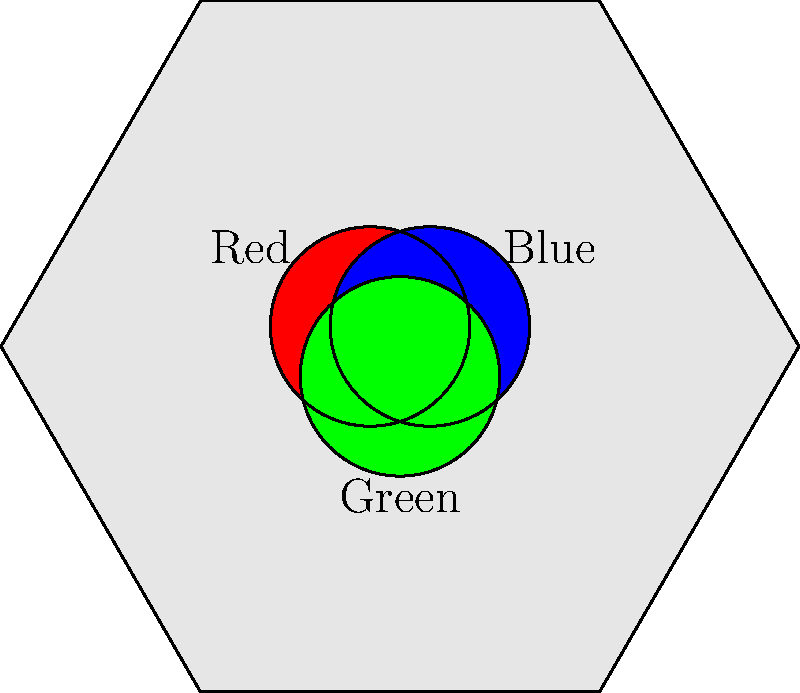Grandpa's old motorcycle jacket has three colorful patches: red, blue, and green. He tells you that he used to rearrange these patches to create different looks. How many unique ways could Grandpa arrange these three patches on his jacket? Let's approach this step-by-step:

1. We have three distinct patches (red, blue, and green), and we want to arrange all three of them.

2. This is a perfect scenario for using permutations. In permutations, the order matters, which is exactly what we're looking for in arranging patches.

3. The formula for permutations of n distinct objects is:

   $$P(n) = n!$$

   Where $n!$ means the factorial of $n$.

4. In this case, $n = 3$ (for the three patches).

5. So, we calculate:

   $$P(3) = 3! = 3 \times 2 \times 1 = 6$$

6. We can list out these 6 arrangements to verify:
   - Red, Blue, Green
   - Red, Green, Blue
   - Blue, Red, Green
   - Blue, Green, Red
   - Green, Red, Blue
   - Green, Blue, Red

Therefore, Grandpa could arrange the three patches in 6 unique ways.
Answer: 6 ways 